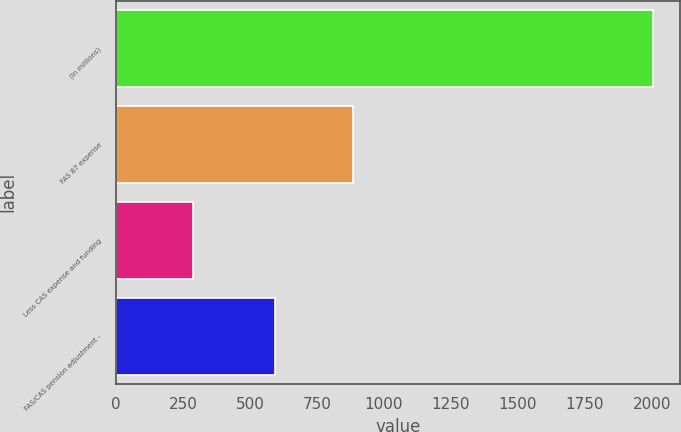Convert chart to OTSL. <chart><loc_0><loc_0><loc_500><loc_500><bar_chart><fcel>(In millions)<fcel>FAS 87 expense<fcel>Less CAS expense and funding<fcel>FAS/CAS pension adjustment -<nl><fcel>2004<fcel>884<fcel>289<fcel>595<nl></chart> 